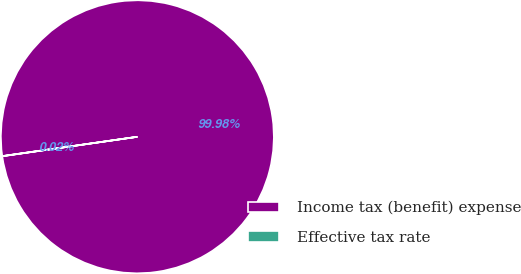<chart> <loc_0><loc_0><loc_500><loc_500><pie_chart><fcel>Income tax (benefit) expense<fcel>Effective tax rate<nl><fcel>99.98%<fcel>0.02%<nl></chart> 